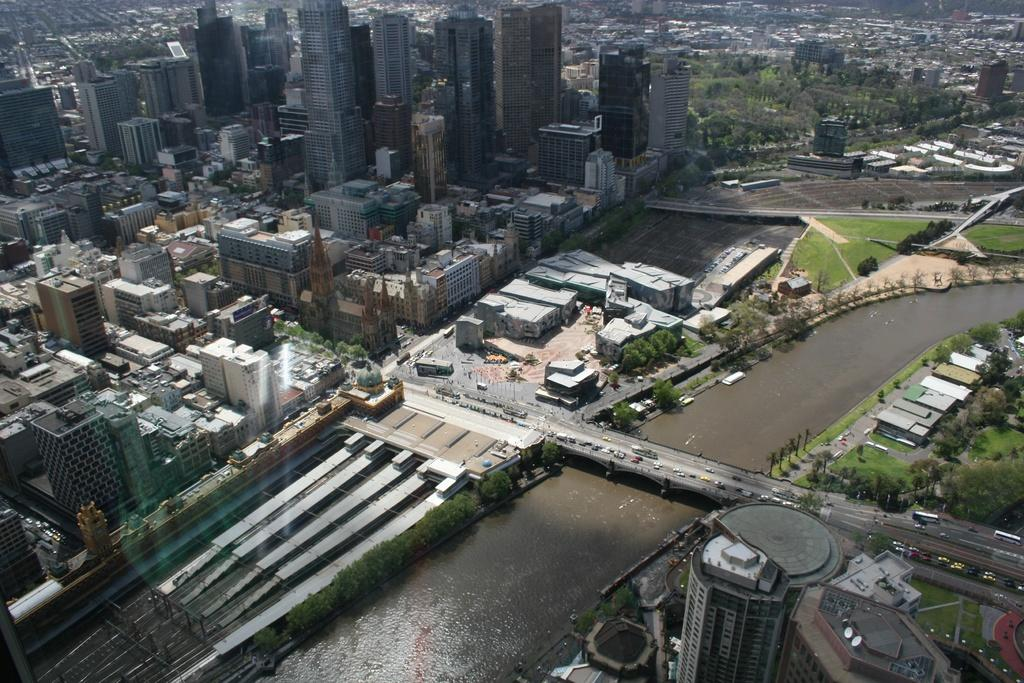What type of view is shown in the image? The image is an aerial view of a city. What can be seen in the middle of the image? There is a canal in the middle of the image. What is above the canal? There is: There is a bridge above the canal. What is on the bridge? Vehicles are present on the bridge. What else can be seen in the image? There are buildings visible in the image. Can you see any beggars in the image? There is no mention of a beggar in the image, so it cannot be determined if one is present. What type of creature is swimming in the canal in the image? There is no creature visible in the canal in the image. 